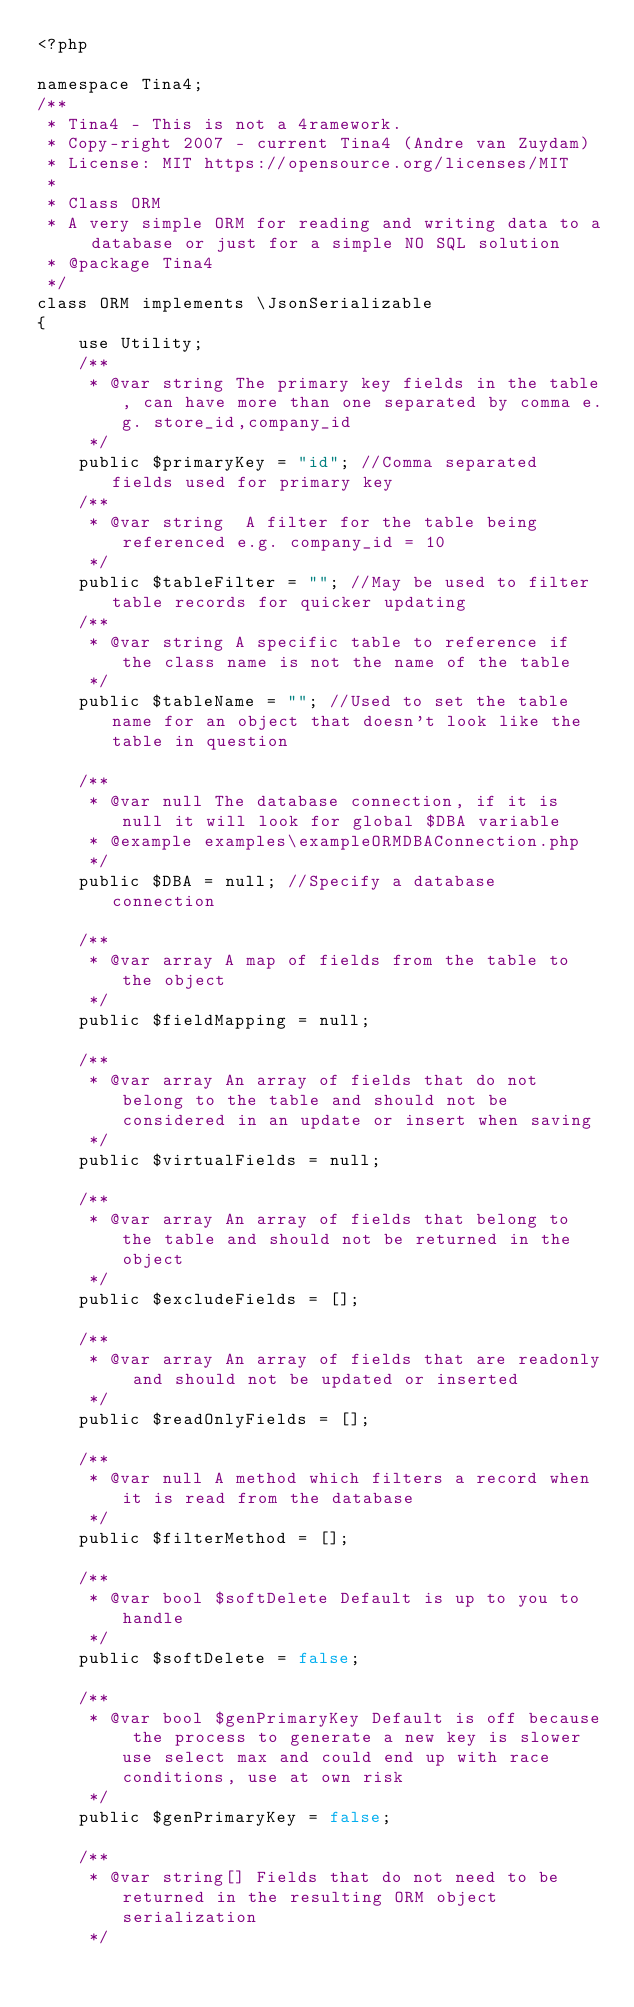Convert code to text. <code><loc_0><loc_0><loc_500><loc_500><_PHP_><?php

namespace Tina4;
/**
 * Tina4 - This is not a 4ramework.
 * Copy-right 2007 - current Tina4 (Andre van Zuydam)
 * License: MIT https://opensource.org/licenses/MIT
 *
 * Class ORM
 * A very simple ORM for reading and writing data to a database or just for a simple NO SQL solution
 * @package Tina4
 */
class ORM implements \JsonSerializable
{
    use Utility;
    /**
     * @var string The primary key fields in the table, can have more than one separated by comma e.g. store_id,company_id
     */
    public $primaryKey = "id"; //Comma separated fields used for primary key
    /**
     * @var string  A filter for the table being referenced e.g. company_id = 10
     */
    public $tableFilter = ""; //May be used to filter table records for quicker updating
    /**
     * @var string A specific table to reference if the class name is not the name of the table
     */
    public $tableName = ""; //Used to set the table name for an object that doesn't look like the table in question

    /**
     * @var null The database connection, if it is null it will look for global $DBA variable
     * @example examples\exampleORMDBAConnection.php
     */
    public $DBA = null; //Specify a database connection

    /**
     * @var array A map of fields from the table to the object
     */
    public $fieldMapping = null;

    /**
     * @var array An array of fields that do not belong to the table and should not be considered in an update or insert when saving
     */
    public $virtualFields = null;

    /**
     * @var array An array of fields that belong to the table and should not be returned in the object
     */
    public $excludeFields = [];

    /**
     * @var array An array of fields that are readonly and should not be updated or inserted
     */
    public $readOnlyFields = [];

    /**
     * @var null A method which filters a record when it is read from the database
     */
    public $filterMethod = [];

    /**
     * @var bool $softDelete Default is up to you to handle
     */
    public $softDelete = false;

    /**
     * @var bool $genPrimaryKey Default is off because the process to generate a new key is slower use select max and could end up with race conditions, use at own risk
     */
    public $genPrimaryKey = false;

    /**
     * @var string[] Fields that do not need to be returned in the resulting ORM object serialization
     */</code> 